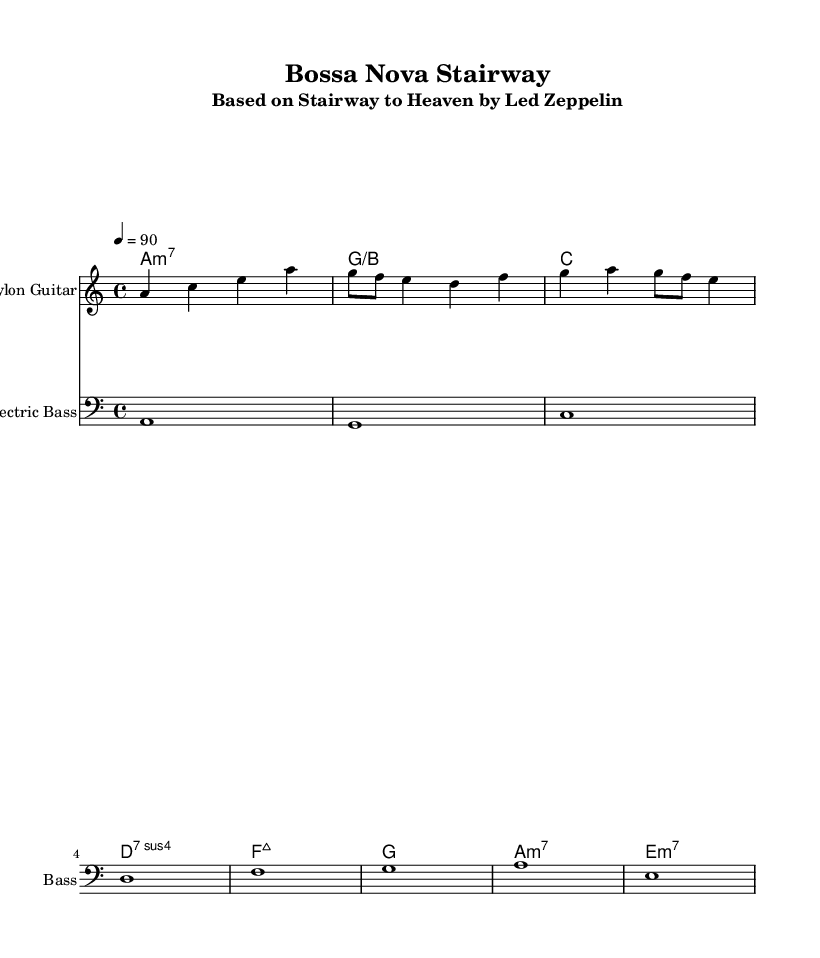What is the key signature of this music? The key signature indicated in the global section is A minor, which has no sharps or flats (the relative major is C major). This is determined from the key mentioned as "a" in the global context.
Answer: A minor What is the time signature of this music? The time signature is shown as 4/4 in the global section, which means there are four beats in each measure and the quarter note gets one beat. This can be confirmed by looking at the time setting included in the global context.
Answer: 4/4 What is the tempo marking for this piece? The tempo is indicated as 4 = 90 in the global section, suggesting that there are 90 beats per minute, with each quarter note representing one beat. This is commonly found in the tempo marking part of the global section.
Answer: 90 What is the first chord of the harmony? The first chord in the harmonyOne section is an A minor seventh chord (a:m7), which can be identified as being written in chord mode with the corresponding note (A) and its quality (minor seventh).
Answer: A minor seventh How many measures are used in the melody section? The melody section contains a total of 10 measures, which can be counted from the notation provided, as each group of notes typically corresponds to one measure. This includes observing the rhythm and rests.
Answer: 10 What is the instrument specified for the melody? The instrument specified for the melody staff is "Nylon Guitar," which can be seen in the staff header of the respective melody part and indicates the type of guitar to be used.
Answer: Nylon Guitar Which decorative technique is implied by the use of 8th notes in the melody? The use of 8th notes in the melody section implies a syncopated rhythm often found in Bossa Nova music, characterized by the placement of notes against the standard rhythmic flow to create a gentle swing feeling. This is a common element in the style's typical rhythmic patterns.
Answer: Syncopation 